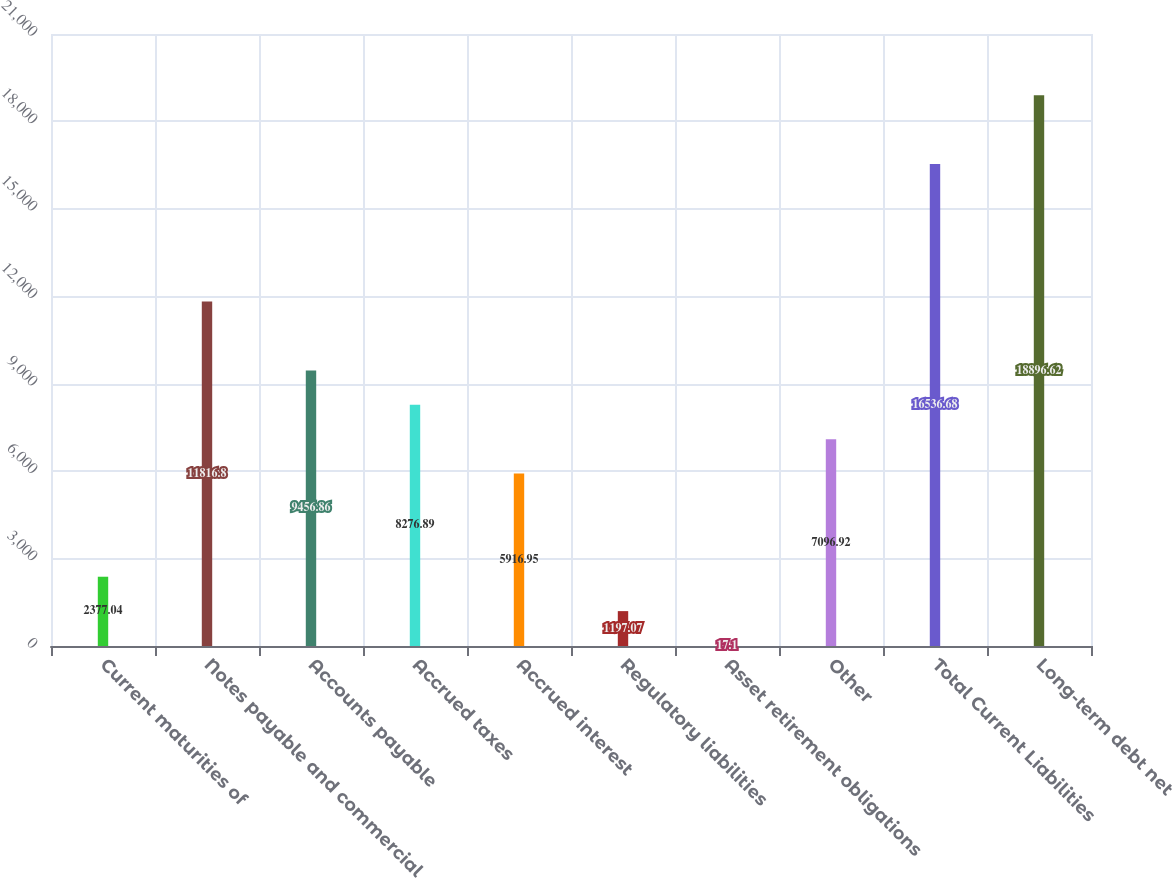Convert chart to OTSL. <chart><loc_0><loc_0><loc_500><loc_500><bar_chart><fcel>Current maturities of<fcel>Notes payable and commercial<fcel>Accounts payable<fcel>Accrued taxes<fcel>Accrued interest<fcel>Regulatory liabilities<fcel>Asset retirement obligations<fcel>Other<fcel>Total Current Liabilities<fcel>Long-term debt net<nl><fcel>2377.04<fcel>11816.8<fcel>9456.86<fcel>8276.89<fcel>5916.95<fcel>1197.07<fcel>17.1<fcel>7096.92<fcel>16536.7<fcel>18896.6<nl></chart> 